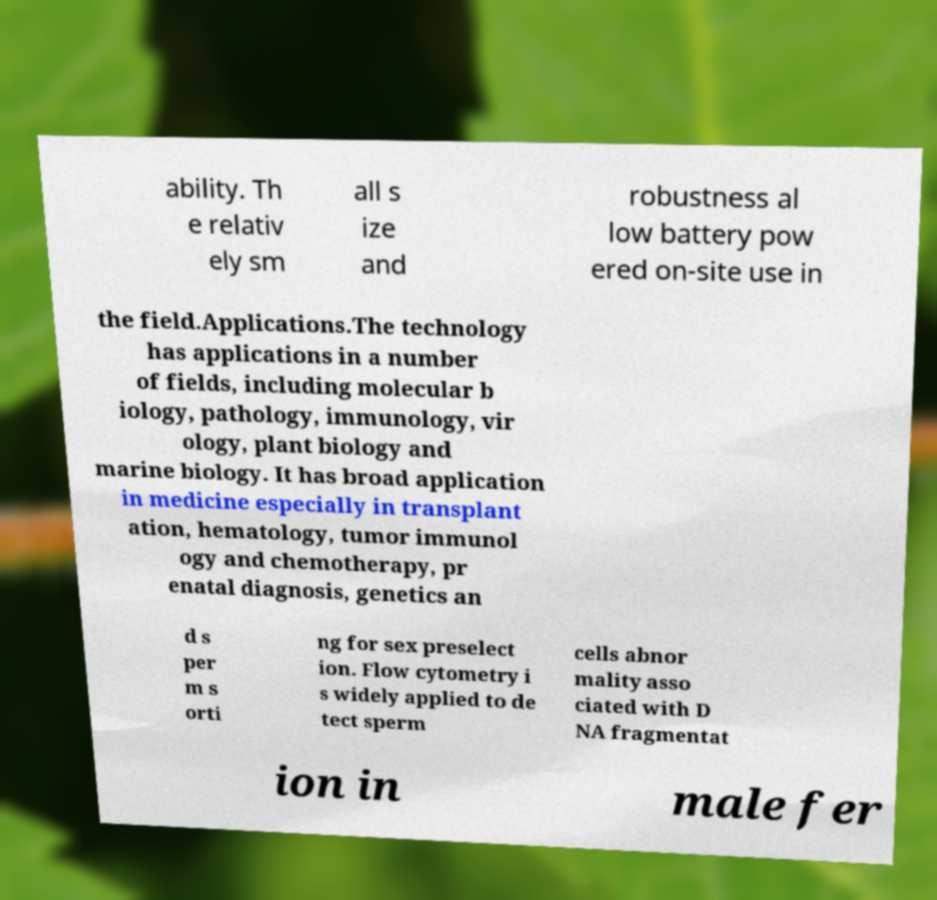What messages or text are displayed in this image? I need them in a readable, typed format. ability. Th e relativ ely sm all s ize and robustness al low battery pow ered on-site use in the field.Applications.The technology has applications in a number of fields, including molecular b iology, pathology, immunology, vir ology, plant biology and marine biology. It has broad application in medicine especially in transplant ation, hematology, tumor immunol ogy and chemotherapy, pr enatal diagnosis, genetics an d s per m s orti ng for sex preselect ion. Flow cytometry i s widely applied to de tect sperm cells abnor mality asso ciated with D NA fragmentat ion in male fer 